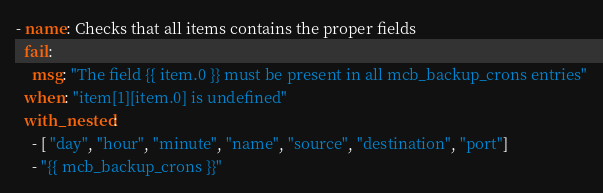Convert code to text. <code><loc_0><loc_0><loc_500><loc_500><_YAML_>- name: Checks that all items contains the proper fields
  fail:
    msg: "The field {{ item.0 }} must be present in all mcb_backup_crons entries"
  when: "item[1][item.0] is undefined"
  with_nested:
    - [ "day", "hour", "minute", "name", "source", "destination", "port"]
    - "{{ mcb_backup_crons }}"</code> 